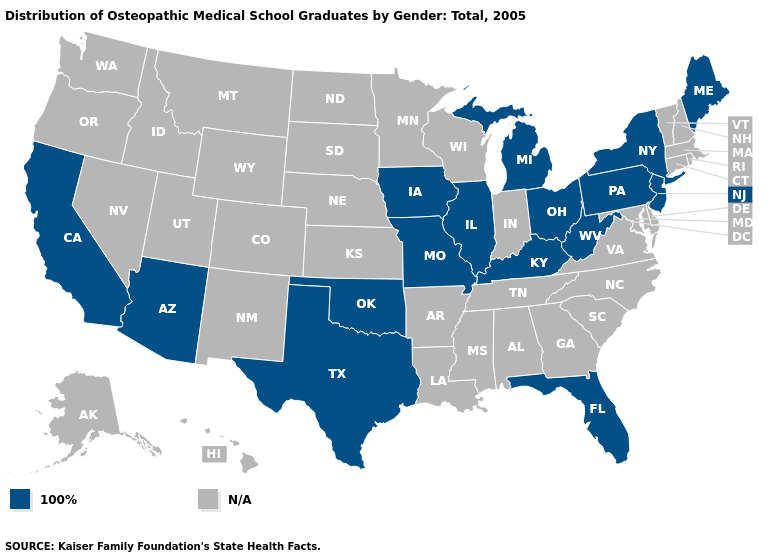What is the highest value in the USA?
Keep it brief. 100%. What is the highest value in the USA?
Keep it brief. 100%. What is the value of New Jersey?
Give a very brief answer. 100%. What is the value of California?
Short answer required. 100%. Among the states that border Delaware , which have the highest value?
Give a very brief answer. New Jersey, Pennsylvania. What is the lowest value in the USA?
Be succinct. 100%. Name the states that have a value in the range N/A?
Give a very brief answer. Alabama, Alaska, Arkansas, Colorado, Connecticut, Delaware, Georgia, Hawaii, Idaho, Indiana, Kansas, Louisiana, Maryland, Massachusetts, Minnesota, Mississippi, Montana, Nebraska, Nevada, New Hampshire, New Mexico, North Carolina, North Dakota, Oregon, Rhode Island, South Carolina, South Dakota, Tennessee, Utah, Vermont, Virginia, Washington, Wisconsin, Wyoming. What is the lowest value in states that border Virginia?
Write a very short answer. 100%. 